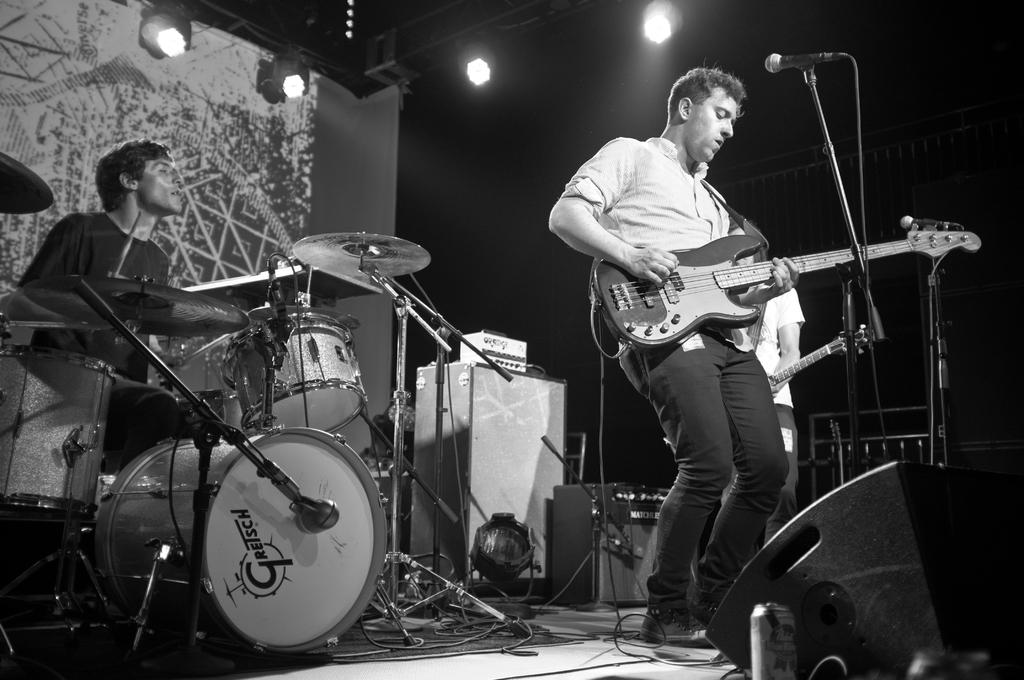What are the two men in the image doing? The two men in the image are playing guitar. How are the men holding the guitars? The men are holding the guitars in their hands. What other musical instrument can be seen in the image? There is a man seated and playing drums in the image. What is used for amplifying sound in the image? There is a microphone in the image. What can be seen at the top of the image? There are lights visible at the top of the image. What type of mailbox can be seen in the image? There is no mailbox present in the image. What is the purpose of the door in the image? There is no door present in the image. 